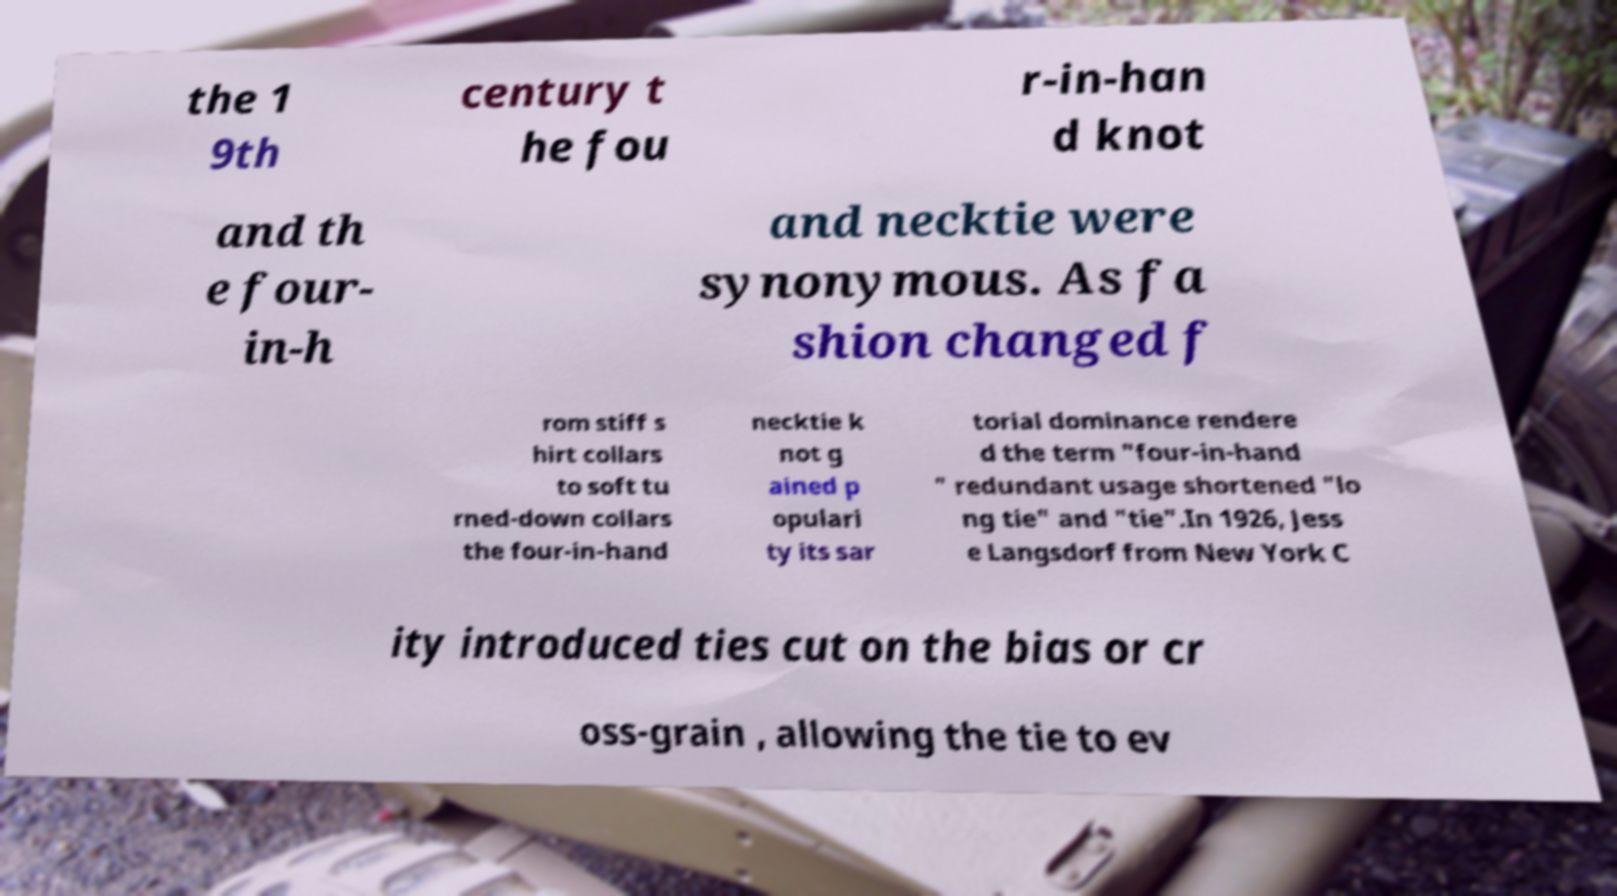Please read and relay the text visible in this image. What does it say? the 1 9th century t he fou r-in-han d knot and th e four- in-h and necktie were synonymous. As fa shion changed f rom stiff s hirt collars to soft tu rned-down collars the four-in-hand necktie k not g ained p opulari ty its sar torial dominance rendere d the term "four-in-hand " redundant usage shortened "lo ng tie" and "tie".In 1926, Jess e Langsdorf from New York C ity introduced ties cut on the bias or cr oss-grain , allowing the tie to ev 